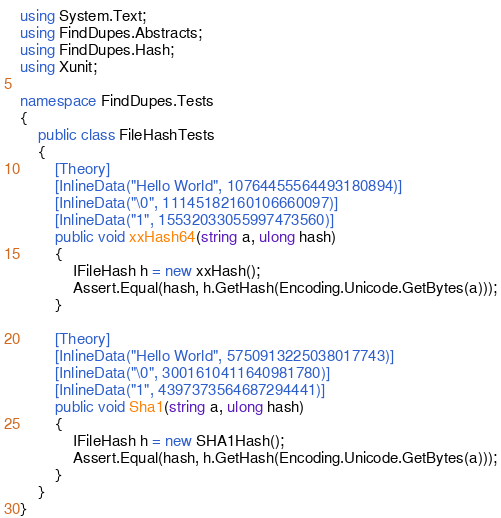<code> <loc_0><loc_0><loc_500><loc_500><_C#_>using System.Text;
using FindDupes.Abstracts;
using FindDupes.Hash;
using Xunit;

namespace FindDupes.Tests
{
    public class FileHashTests
    {
        [Theory]
        [InlineData("Hello World", 10764455564493180894)]
        [InlineData("\0", 11145182160106660097)]
        [InlineData("1", 15532033055997473560)]
        public void xxHash64(string a, ulong hash)
        {
            IFileHash h = new xxHash();
            Assert.Equal(hash, h.GetHash(Encoding.Unicode.GetBytes(a)));
        }

        [Theory]
        [InlineData("Hello World", 5750913225038017743)]
        [InlineData("\0", 3001610411640981780)]
        [InlineData("1", 4397373564687294441)]
        public void Sha1(string a, ulong hash)
        {
            IFileHash h = new SHA1Hash();
            Assert.Equal(hash, h.GetHash(Encoding.Unicode.GetBytes(a)));
        }
    }
}</code> 